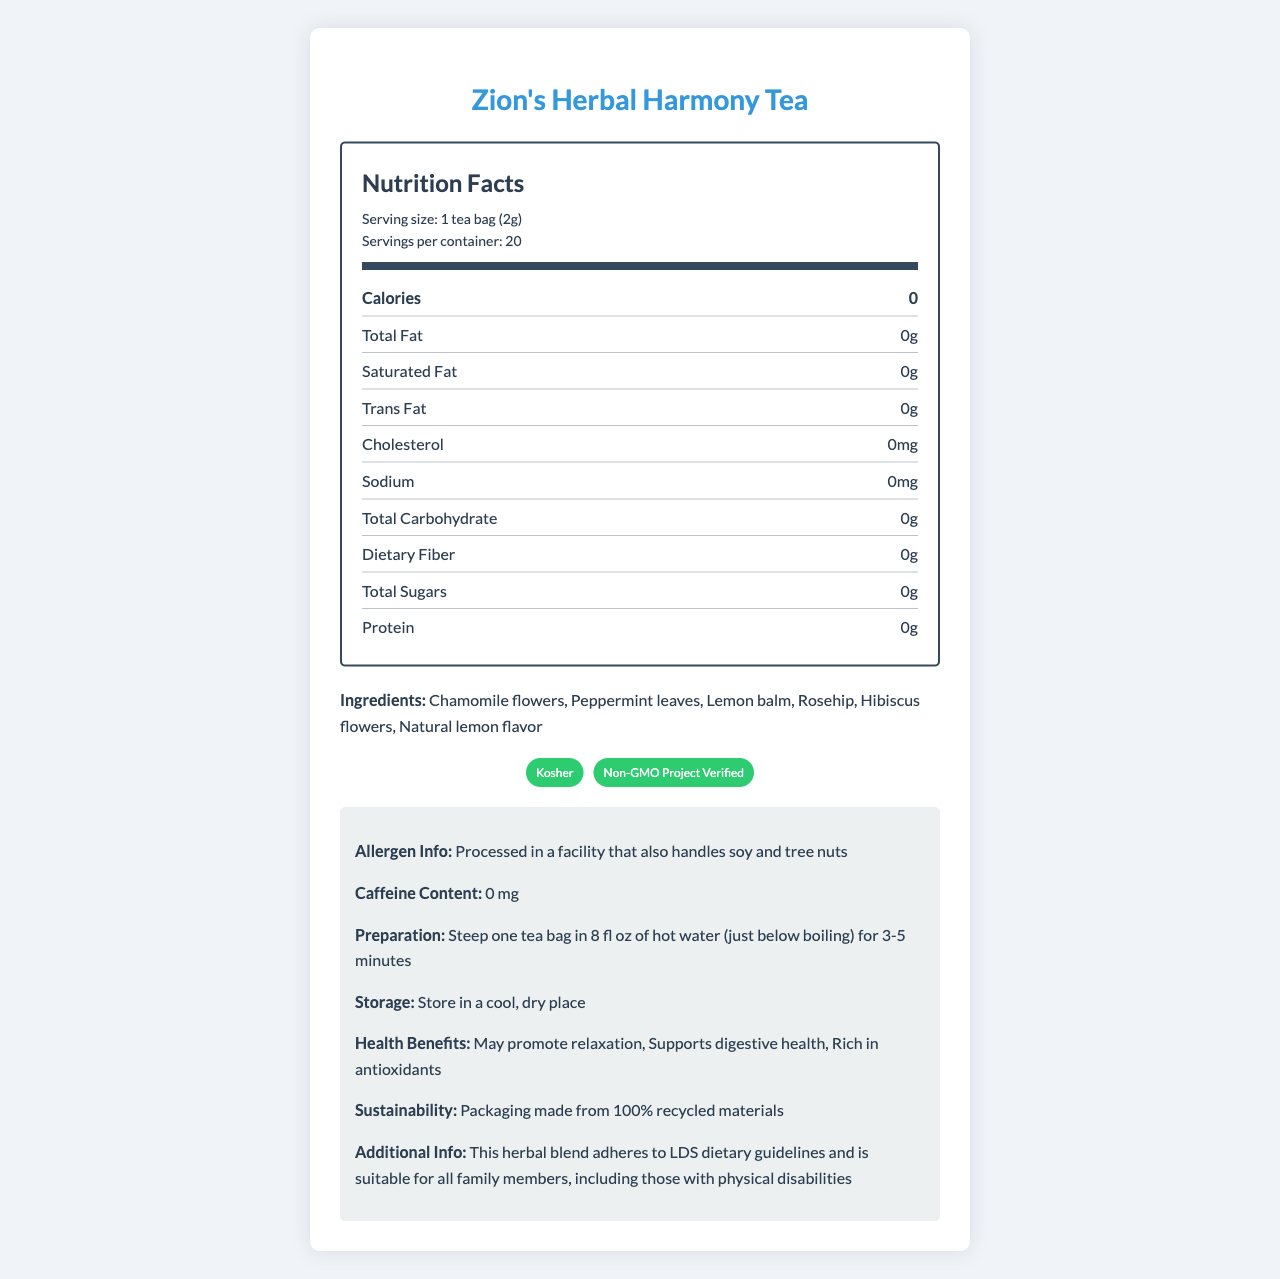what is the serving size for Zion's Herbal Harmony Tea? The serving size is specified at the beginning of the document under the "Nutrition Facts" section.
Answer: 1 tea bag (2g) how many servings are in one container of Zion's Herbal Harmony Tea? The document states that there are 20 servings per container.
Answer: 20 how many calories are in one serving of Zion's Herbal Harmony Tea? The number of calories per serving is listed as 0 in the "Nutrition Facts" section.
Answer: 0 what are the certifications of Zion's Herbal Harmony Tea? These certifications are mentioned in the "certifications" section of the document.
Answer: Kosher, Non-GMO Project Verified what is the preparation instruction for Zion's Herbal Harmony Tea? The preparation instructions are detailed in the "additional info" section under "Preparation."
Answer: Steep one tea bag in 8 fl oz of hot water (just below boiling) for 3-5 minutes what ingredients are included in Zion's Herbal Harmony Tea? The ingredients are listed under the "Ingredients" section.
Answer: Chamomile flowers, Peppermint leaves, Lemon balm, Rosehip, Hibiscus flowers, Natural lemon flavor where should Zion's Herbal Harmony Tea be stored? The storage instructions are given in the "additional info" section under "Storage."
Answer: Store in a cool, dry place how much caffeine does Zion's Herbal Harmony Tea contain? The caffeine content is listed as 0 mg in the "additional info" section.
Answer: 0 mg which of the following is not an ingredient in Zion's Herbal Harmony Tea? A. Mint leaves B. Chamomile flowers C. Rosehip D. Lemon balm Mint leaves are not listed as an ingredient; the correct ingredient is Peppermint leaves.
Answer: A. Mint leaves what are the health benefits of Zion's Herbal Harmony Tea? A. Boosts immune system B. May promote relaxation C. Increases energy D. Aids in weight loss "May promote relaxation" is specified as one of the health benefits in the "additional info" section.
Answer: B. May promote relaxation is Zion's Herbal Harmony Tea suitable for family members with physical disabilities? The document states in the "additional info" section that it is suitable for all family members, including those with physical disabilities.
Answer: Yes summarize the main idea of the document. This summary captures the main features and benefits of Zion's Herbal Harmony Tea as detailed in the document.
Answer: Zion's Herbal Harmony Tea is a low-calorie, caffeine-free herbal tea blend that adheres to LDS dietary guidelines and provides various health benefits. It contains a blend of chamomile flowers, peppermint leaves, lemon balm, rosehip, hibiscus flowers, and natural lemon flavor and is certified Kosher and Non-GMO Project Verified. The tea promotes relaxation, supports digestive health, and is rich in antioxidants. It is processed in a facility that handles soy and tree nuts, should be stored in a cool, dry place, and prepared by steeping in hot water. The packaging is made from 100% recycled materials. what is the manufacturer's address for Zion's Herbal Harmony Tea? The document specifies the manufacturer as Deseret Wellness Teas in Provo, UT, but does not provide a complete address.
Answer: Not enough information 